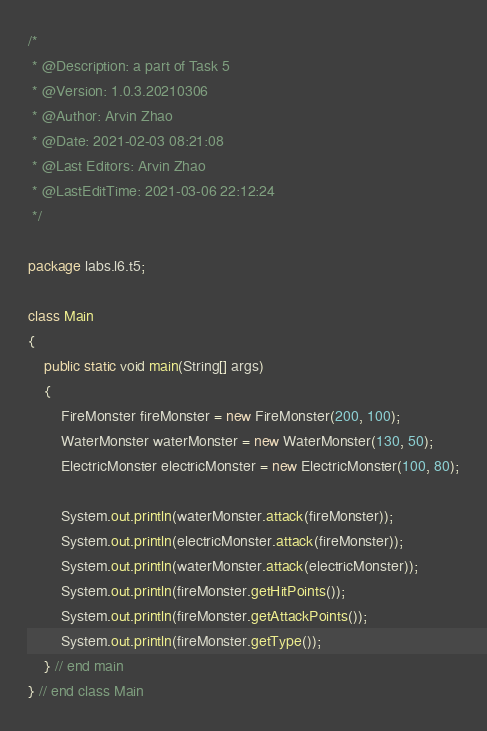Convert code to text. <code><loc_0><loc_0><loc_500><loc_500><_Java_>/*
 * @Description: a part of Task 5
 * @Version: 1.0.3.20210306
 * @Author: Arvin Zhao
 * @Date: 2021-02-03 08:21:08
 * @Last Editors: Arvin Zhao
 * @LastEditTime: 2021-03-06 22:12:24
 */

package labs.l6.t5;

class Main
{
    public static void main(String[] args)
    {
        FireMonster fireMonster = new FireMonster(200, 100);
        WaterMonster waterMonster = new WaterMonster(130, 50);
        ElectricMonster electricMonster = new ElectricMonster(100, 80);

        System.out.println(waterMonster.attack(fireMonster));
        System.out.println(electricMonster.attack(fireMonster));
        System.out.println(waterMonster.attack(electricMonster));
        System.out.println(fireMonster.getHitPoints());
        System.out.println(fireMonster.getAttackPoints());
        System.out.println(fireMonster.getType());
    } // end main
} // end class Main</code> 